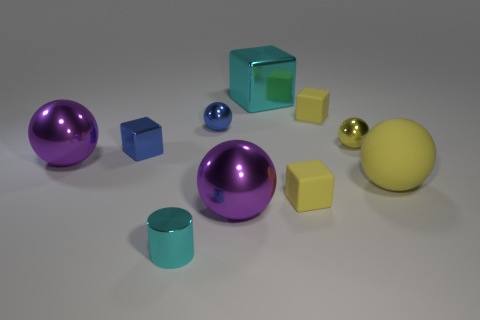What size is the purple shiny sphere behind the small yellow matte block to the left of the yellow thing behind the small yellow sphere?
Your answer should be compact. Large. There is another tiny metallic object that is the same shape as the tiny yellow metal object; what is its color?
Provide a short and direct response. Blue. Are there more rubber cubes that are on the left side of the tiny blue shiny ball than small purple rubber objects?
Your answer should be very brief. No. Is the shape of the large cyan thing the same as the big metal thing in front of the large yellow ball?
Offer a very short reply. No. Are there any other things that have the same size as the yellow shiny sphere?
Give a very brief answer. Yes. What size is the yellow matte object that is the same shape as the yellow metal object?
Your answer should be compact. Large. Are there more blue shiny balls than small spheres?
Your answer should be very brief. No. Is the big cyan metal object the same shape as the yellow shiny object?
Make the answer very short. No. The cyan object that is in front of the big shiny thing behind the tiny yellow shiny object is made of what material?
Keep it short and to the point. Metal. What is the material of the big block that is the same color as the small cylinder?
Keep it short and to the point. Metal. 